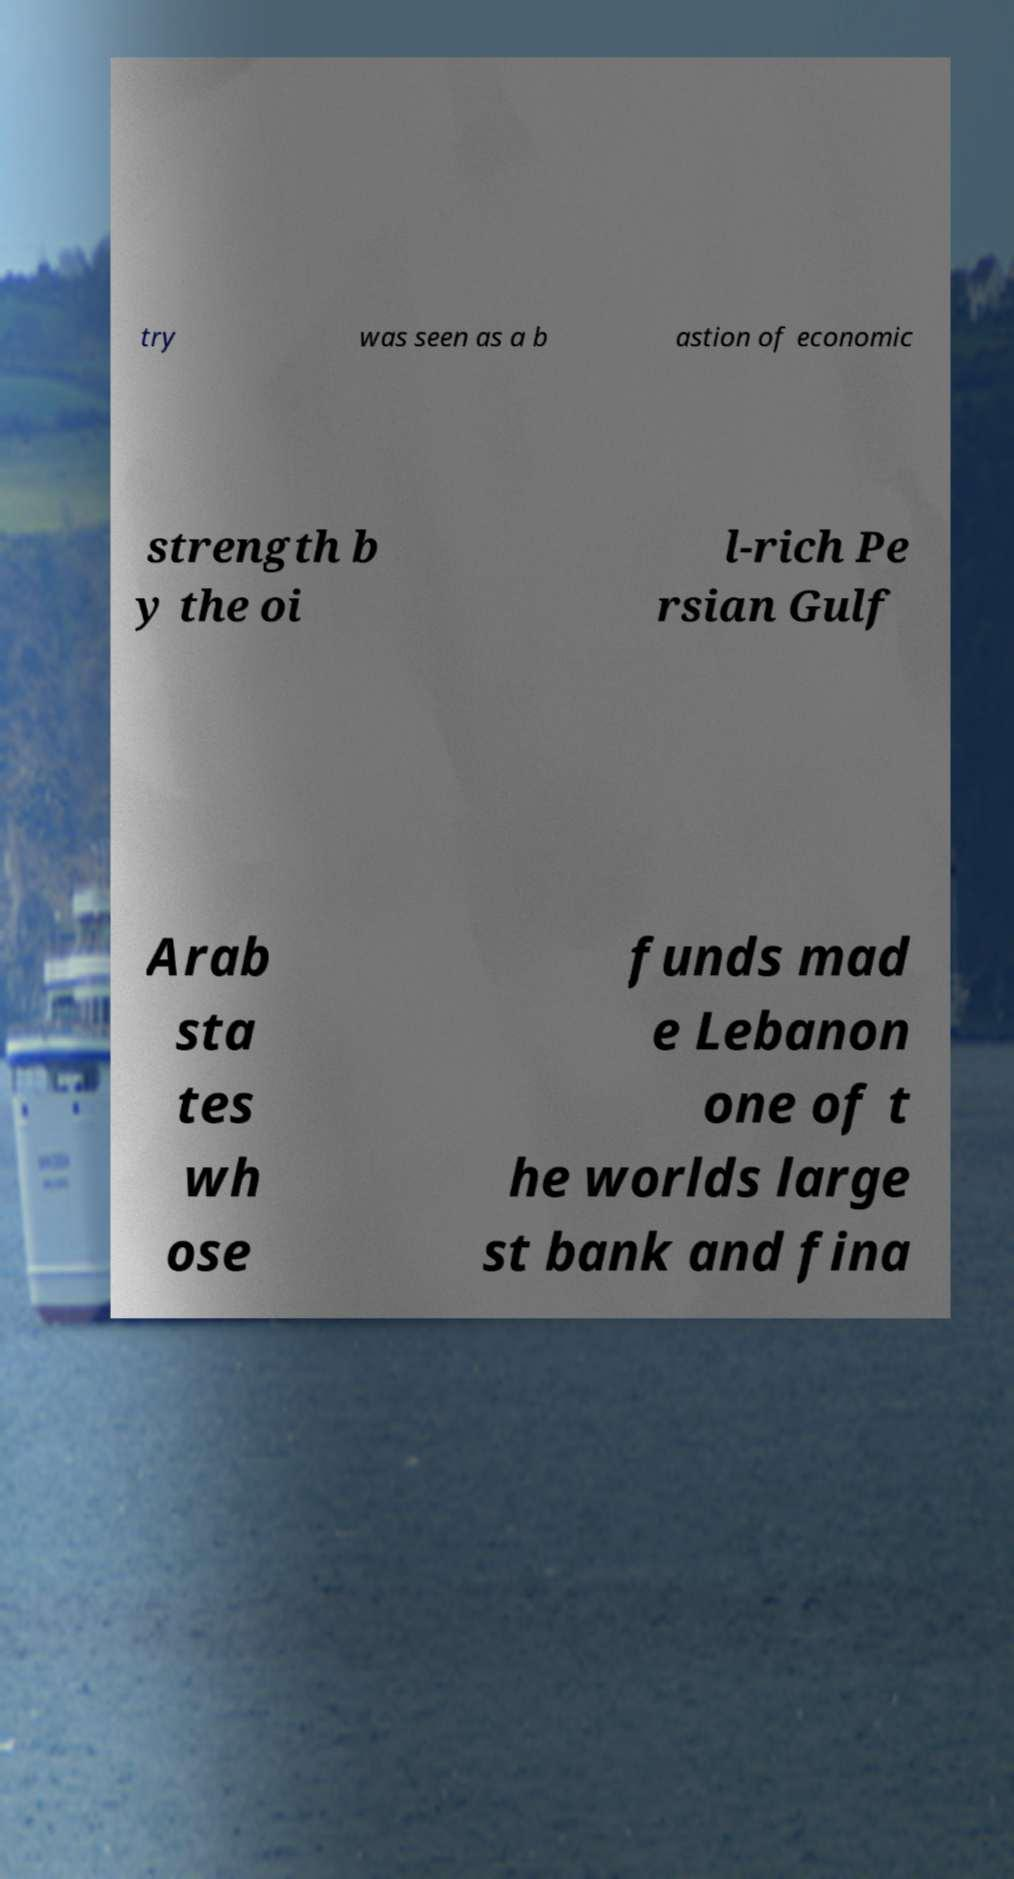Please read and relay the text visible in this image. What does it say? try was seen as a b astion of economic strength b y the oi l-rich Pe rsian Gulf Arab sta tes wh ose funds mad e Lebanon one of t he worlds large st bank and fina 